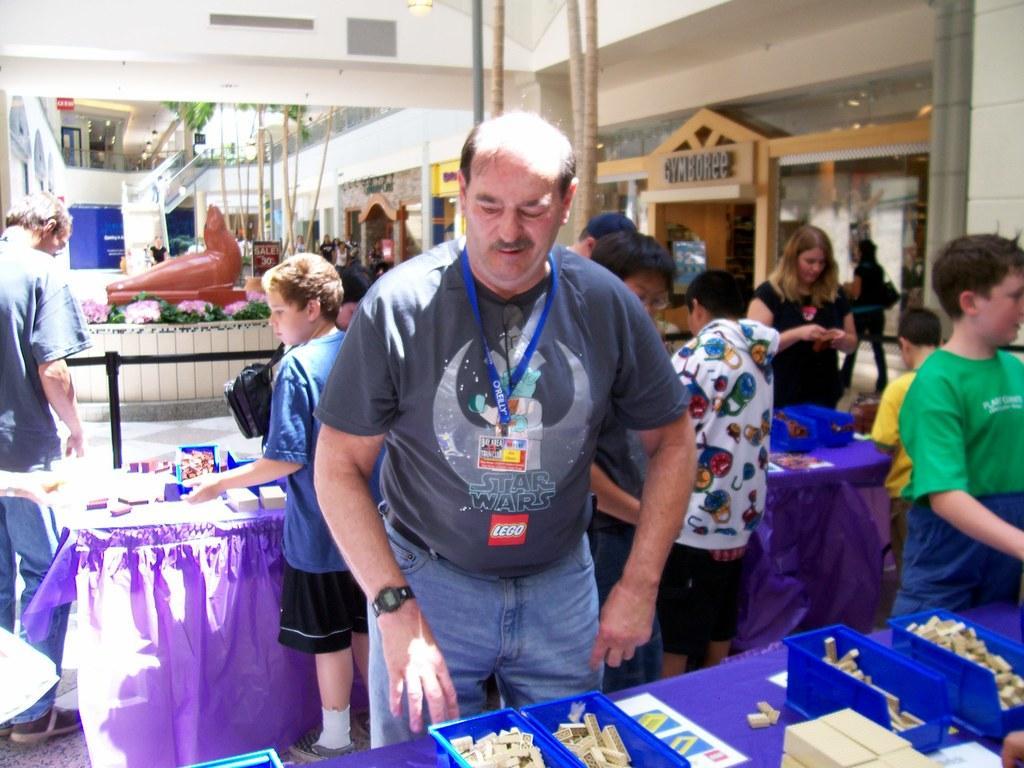Can you describe this image briefly? In this image I can see group of people are standing in front of tables. On the tables I can see some objects. In the background I can see trees, wall, stairs and other objects on the ground. 